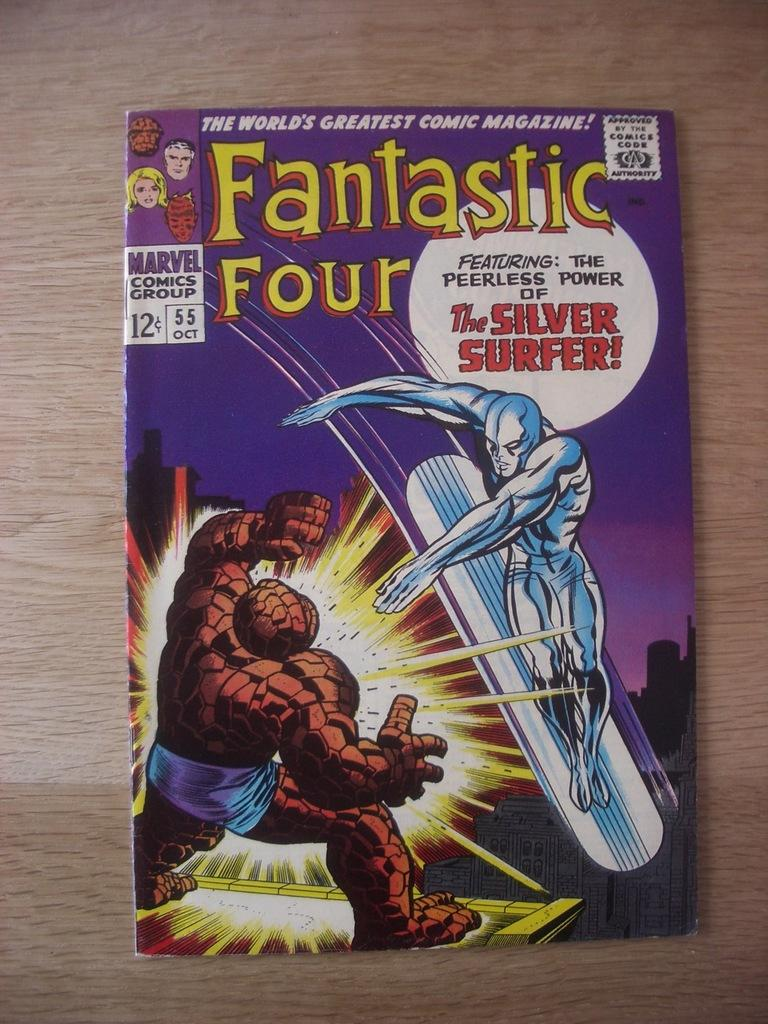<image>
Relay a brief, clear account of the picture shown. A Fantastic Four comic book features the Silver Surfer. 